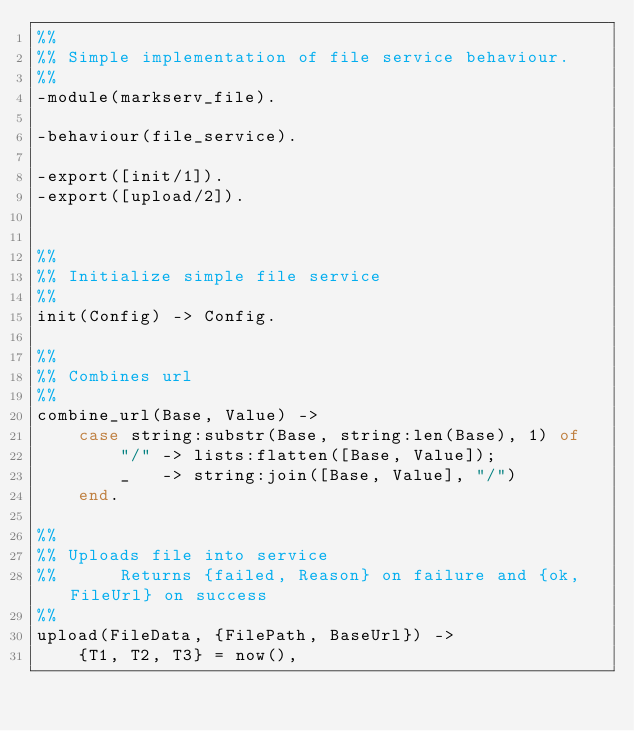<code> <loc_0><loc_0><loc_500><loc_500><_Erlang_>%%
%% Simple implementation of file service behaviour.
%%
-module(markserv_file).

-behaviour(file_service).

-export([init/1]).
-export([upload/2]).


%%
%% Initialize simple file service
%%
init(Config) -> Config.

%%
%% Combines url
%%
combine_url(Base, Value) ->
    case string:substr(Base, string:len(Base), 1) of
        "/" -> lists:flatten([Base, Value]);
        _   -> string:join([Base, Value], "/")
    end.

%%
%% Uploads file into service
%%      Returns {failed, Reason} on failure and {ok, FileUrl} on success
%%
upload(FileData, {FilePath, BaseUrl}) ->
    {T1, T2, T3} = now(),</code> 